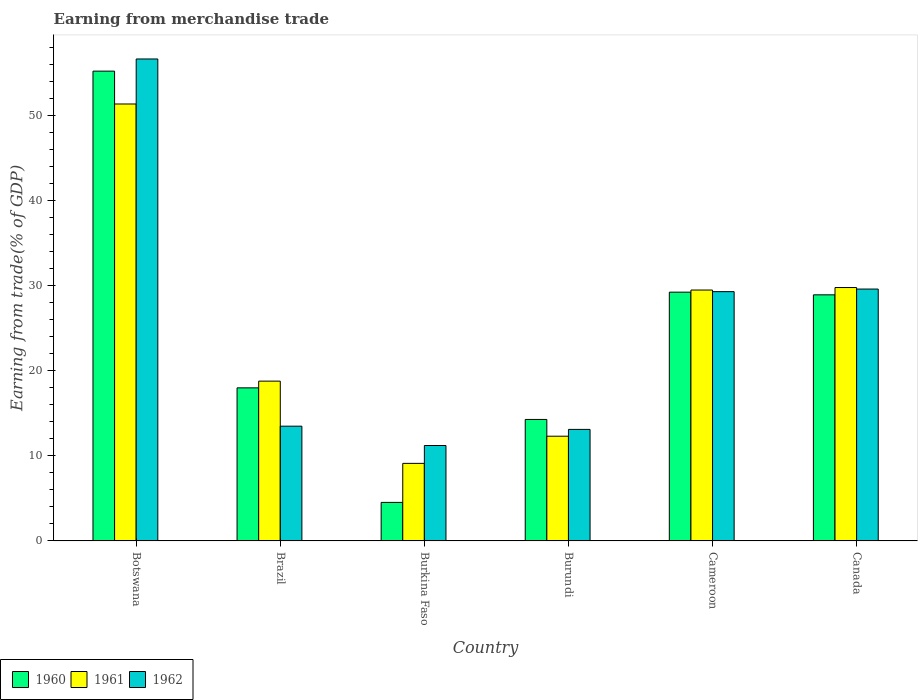How many different coloured bars are there?
Provide a short and direct response. 3. Are the number of bars per tick equal to the number of legend labels?
Provide a succinct answer. Yes. Are the number of bars on each tick of the X-axis equal?
Make the answer very short. Yes. How many bars are there on the 2nd tick from the right?
Your answer should be very brief. 3. What is the label of the 3rd group of bars from the left?
Keep it short and to the point. Burkina Faso. In how many cases, is the number of bars for a given country not equal to the number of legend labels?
Provide a short and direct response. 0. What is the earnings from trade in 1962 in Brazil?
Your response must be concise. 13.49. Across all countries, what is the maximum earnings from trade in 1961?
Keep it short and to the point. 51.38. Across all countries, what is the minimum earnings from trade in 1961?
Your answer should be very brief. 9.12. In which country was the earnings from trade in 1962 maximum?
Make the answer very short. Botswana. In which country was the earnings from trade in 1962 minimum?
Your answer should be compact. Burkina Faso. What is the total earnings from trade in 1960 in the graph?
Your answer should be very brief. 150.25. What is the difference between the earnings from trade in 1961 in Burkina Faso and that in Canada?
Make the answer very short. -20.68. What is the difference between the earnings from trade in 1960 in Burkina Faso and the earnings from trade in 1961 in Canada?
Your response must be concise. -25.26. What is the average earnings from trade in 1960 per country?
Provide a short and direct response. 25.04. What is the difference between the earnings from trade of/in 1962 and earnings from trade of/in 1961 in Canada?
Offer a very short reply. -0.18. What is the ratio of the earnings from trade in 1960 in Botswana to that in Burundi?
Provide a succinct answer. 3.87. Is the earnings from trade in 1961 in Brazil less than that in Burkina Faso?
Your answer should be very brief. No. What is the difference between the highest and the second highest earnings from trade in 1961?
Your response must be concise. -21.88. What is the difference between the highest and the lowest earnings from trade in 1961?
Provide a succinct answer. 42.26. In how many countries, is the earnings from trade in 1962 greater than the average earnings from trade in 1962 taken over all countries?
Keep it short and to the point. 3. Is the sum of the earnings from trade in 1960 in Brazil and Cameroon greater than the maximum earnings from trade in 1961 across all countries?
Ensure brevity in your answer.  No. Is it the case that in every country, the sum of the earnings from trade in 1961 and earnings from trade in 1960 is greater than the earnings from trade in 1962?
Ensure brevity in your answer.  Yes. Are the values on the major ticks of Y-axis written in scientific E-notation?
Offer a very short reply. No. Does the graph contain any zero values?
Offer a very short reply. No. Does the graph contain grids?
Your answer should be very brief. No. How many legend labels are there?
Ensure brevity in your answer.  3. What is the title of the graph?
Your response must be concise. Earning from merchandise trade. What is the label or title of the Y-axis?
Give a very brief answer. Earning from trade(% of GDP). What is the Earning from trade(% of GDP) of 1960 in Botswana?
Give a very brief answer. 55.24. What is the Earning from trade(% of GDP) in 1961 in Botswana?
Your response must be concise. 51.38. What is the Earning from trade(% of GDP) of 1962 in Botswana?
Offer a terse response. 56.67. What is the Earning from trade(% of GDP) of 1960 in Brazil?
Give a very brief answer. 18. What is the Earning from trade(% of GDP) of 1961 in Brazil?
Your response must be concise. 18.79. What is the Earning from trade(% of GDP) of 1962 in Brazil?
Your response must be concise. 13.49. What is the Earning from trade(% of GDP) of 1960 in Burkina Faso?
Provide a short and direct response. 4.53. What is the Earning from trade(% of GDP) in 1961 in Burkina Faso?
Your response must be concise. 9.12. What is the Earning from trade(% of GDP) of 1962 in Burkina Faso?
Ensure brevity in your answer.  11.22. What is the Earning from trade(% of GDP) of 1960 in Burundi?
Provide a succinct answer. 14.29. What is the Earning from trade(% of GDP) in 1961 in Burundi?
Ensure brevity in your answer.  12.32. What is the Earning from trade(% of GDP) in 1962 in Burundi?
Make the answer very short. 13.11. What is the Earning from trade(% of GDP) of 1960 in Cameroon?
Offer a terse response. 29.25. What is the Earning from trade(% of GDP) in 1961 in Cameroon?
Keep it short and to the point. 29.5. What is the Earning from trade(% of GDP) of 1962 in Cameroon?
Make the answer very short. 29.31. What is the Earning from trade(% of GDP) of 1960 in Canada?
Provide a short and direct response. 28.94. What is the Earning from trade(% of GDP) of 1961 in Canada?
Give a very brief answer. 29.8. What is the Earning from trade(% of GDP) in 1962 in Canada?
Keep it short and to the point. 29.62. Across all countries, what is the maximum Earning from trade(% of GDP) in 1960?
Ensure brevity in your answer.  55.24. Across all countries, what is the maximum Earning from trade(% of GDP) of 1961?
Your answer should be compact. 51.38. Across all countries, what is the maximum Earning from trade(% of GDP) in 1962?
Keep it short and to the point. 56.67. Across all countries, what is the minimum Earning from trade(% of GDP) of 1960?
Ensure brevity in your answer.  4.53. Across all countries, what is the minimum Earning from trade(% of GDP) of 1961?
Your answer should be very brief. 9.12. Across all countries, what is the minimum Earning from trade(% of GDP) in 1962?
Provide a succinct answer. 11.22. What is the total Earning from trade(% of GDP) of 1960 in the graph?
Make the answer very short. 150.25. What is the total Earning from trade(% of GDP) of 1961 in the graph?
Your response must be concise. 150.9. What is the total Earning from trade(% of GDP) of 1962 in the graph?
Your answer should be very brief. 153.43. What is the difference between the Earning from trade(% of GDP) in 1960 in Botswana and that in Brazil?
Offer a terse response. 37.24. What is the difference between the Earning from trade(% of GDP) of 1961 in Botswana and that in Brazil?
Give a very brief answer. 32.59. What is the difference between the Earning from trade(% of GDP) of 1962 in Botswana and that in Brazil?
Make the answer very short. 43.18. What is the difference between the Earning from trade(% of GDP) of 1960 in Botswana and that in Burkina Faso?
Keep it short and to the point. 50.71. What is the difference between the Earning from trade(% of GDP) of 1961 in Botswana and that in Burkina Faso?
Make the answer very short. 42.26. What is the difference between the Earning from trade(% of GDP) of 1962 in Botswana and that in Burkina Faso?
Keep it short and to the point. 45.45. What is the difference between the Earning from trade(% of GDP) of 1960 in Botswana and that in Burundi?
Ensure brevity in your answer.  40.96. What is the difference between the Earning from trade(% of GDP) in 1961 in Botswana and that in Burundi?
Make the answer very short. 39.06. What is the difference between the Earning from trade(% of GDP) in 1962 in Botswana and that in Burundi?
Offer a very short reply. 43.56. What is the difference between the Earning from trade(% of GDP) of 1960 in Botswana and that in Cameroon?
Keep it short and to the point. 25.99. What is the difference between the Earning from trade(% of GDP) in 1961 in Botswana and that in Cameroon?
Your answer should be very brief. 21.88. What is the difference between the Earning from trade(% of GDP) of 1962 in Botswana and that in Cameroon?
Ensure brevity in your answer.  27.36. What is the difference between the Earning from trade(% of GDP) in 1960 in Botswana and that in Canada?
Make the answer very short. 26.3. What is the difference between the Earning from trade(% of GDP) in 1961 in Botswana and that in Canada?
Your response must be concise. 21.58. What is the difference between the Earning from trade(% of GDP) in 1962 in Botswana and that in Canada?
Ensure brevity in your answer.  27.05. What is the difference between the Earning from trade(% of GDP) of 1960 in Brazil and that in Burkina Faso?
Provide a short and direct response. 13.47. What is the difference between the Earning from trade(% of GDP) in 1961 in Brazil and that in Burkina Faso?
Your response must be concise. 9.67. What is the difference between the Earning from trade(% of GDP) in 1962 in Brazil and that in Burkina Faso?
Offer a terse response. 2.27. What is the difference between the Earning from trade(% of GDP) in 1960 in Brazil and that in Burundi?
Make the answer very short. 3.72. What is the difference between the Earning from trade(% of GDP) in 1961 in Brazil and that in Burundi?
Ensure brevity in your answer.  6.47. What is the difference between the Earning from trade(% of GDP) of 1962 in Brazil and that in Burundi?
Your answer should be very brief. 0.38. What is the difference between the Earning from trade(% of GDP) in 1960 in Brazil and that in Cameroon?
Your response must be concise. -11.25. What is the difference between the Earning from trade(% of GDP) in 1961 in Brazil and that in Cameroon?
Provide a succinct answer. -10.71. What is the difference between the Earning from trade(% of GDP) in 1962 in Brazil and that in Cameroon?
Offer a terse response. -15.82. What is the difference between the Earning from trade(% of GDP) in 1960 in Brazil and that in Canada?
Make the answer very short. -10.94. What is the difference between the Earning from trade(% of GDP) in 1961 in Brazil and that in Canada?
Offer a very short reply. -11.01. What is the difference between the Earning from trade(% of GDP) of 1962 in Brazil and that in Canada?
Provide a short and direct response. -16.12. What is the difference between the Earning from trade(% of GDP) of 1960 in Burkina Faso and that in Burundi?
Your answer should be compact. -9.75. What is the difference between the Earning from trade(% of GDP) of 1961 in Burkina Faso and that in Burundi?
Provide a short and direct response. -3.19. What is the difference between the Earning from trade(% of GDP) of 1962 in Burkina Faso and that in Burundi?
Give a very brief answer. -1.89. What is the difference between the Earning from trade(% of GDP) of 1960 in Burkina Faso and that in Cameroon?
Offer a terse response. -24.72. What is the difference between the Earning from trade(% of GDP) of 1961 in Burkina Faso and that in Cameroon?
Offer a very short reply. -20.38. What is the difference between the Earning from trade(% of GDP) of 1962 in Burkina Faso and that in Cameroon?
Ensure brevity in your answer.  -18.09. What is the difference between the Earning from trade(% of GDP) in 1960 in Burkina Faso and that in Canada?
Offer a terse response. -24.41. What is the difference between the Earning from trade(% of GDP) in 1961 in Burkina Faso and that in Canada?
Your answer should be very brief. -20.68. What is the difference between the Earning from trade(% of GDP) of 1962 in Burkina Faso and that in Canada?
Your response must be concise. -18.4. What is the difference between the Earning from trade(% of GDP) in 1960 in Burundi and that in Cameroon?
Your answer should be compact. -14.97. What is the difference between the Earning from trade(% of GDP) of 1961 in Burundi and that in Cameroon?
Provide a short and direct response. -17.19. What is the difference between the Earning from trade(% of GDP) of 1962 in Burundi and that in Cameroon?
Keep it short and to the point. -16.2. What is the difference between the Earning from trade(% of GDP) of 1960 in Burundi and that in Canada?
Provide a succinct answer. -14.65. What is the difference between the Earning from trade(% of GDP) in 1961 in Burundi and that in Canada?
Provide a short and direct response. -17.48. What is the difference between the Earning from trade(% of GDP) of 1962 in Burundi and that in Canada?
Give a very brief answer. -16.5. What is the difference between the Earning from trade(% of GDP) of 1960 in Cameroon and that in Canada?
Keep it short and to the point. 0.32. What is the difference between the Earning from trade(% of GDP) of 1961 in Cameroon and that in Canada?
Your response must be concise. -0.3. What is the difference between the Earning from trade(% of GDP) of 1962 in Cameroon and that in Canada?
Your answer should be compact. -0.3. What is the difference between the Earning from trade(% of GDP) of 1960 in Botswana and the Earning from trade(% of GDP) of 1961 in Brazil?
Ensure brevity in your answer.  36.45. What is the difference between the Earning from trade(% of GDP) of 1960 in Botswana and the Earning from trade(% of GDP) of 1962 in Brazil?
Your response must be concise. 41.75. What is the difference between the Earning from trade(% of GDP) of 1961 in Botswana and the Earning from trade(% of GDP) of 1962 in Brazil?
Offer a very short reply. 37.88. What is the difference between the Earning from trade(% of GDP) in 1960 in Botswana and the Earning from trade(% of GDP) in 1961 in Burkina Faso?
Give a very brief answer. 46.12. What is the difference between the Earning from trade(% of GDP) in 1960 in Botswana and the Earning from trade(% of GDP) in 1962 in Burkina Faso?
Provide a succinct answer. 44.02. What is the difference between the Earning from trade(% of GDP) in 1961 in Botswana and the Earning from trade(% of GDP) in 1962 in Burkina Faso?
Keep it short and to the point. 40.16. What is the difference between the Earning from trade(% of GDP) in 1960 in Botswana and the Earning from trade(% of GDP) in 1961 in Burundi?
Your answer should be very brief. 42.93. What is the difference between the Earning from trade(% of GDP) in 1960 in Botswana and the Earning from trade(% of GDP) in 1962 in Burundi?
Your response must be concise. 42.13. What is the difference between the Earning from trade(% of GDP) of 1961 in Botswana and the Earning from trade(% of GDP) of 1962 in Burundi?
Your answer should be very brief. 38.26. What is the difference between the Earning from trade(% of GDP) in 1960 in Botswana and the Earning from trade(% of GDP) in 1961 in Cameroon?
Your response must be concise. 25.74. What is the difference between the Earning from trade(% of GDP) in 1960 in Botswana and the Earning from trade(% of GDP) in 1962 in Cameroon?
Your response must be concise. 25.93. What is the difference between the Earning from trade(% of GDP) of 1961 in Botswana and the Earning from trade(% of GDP) of 1962 in Cameroon?
Ensure brevity in your answer.  22.07. What is the difference between the Earning from trade(% of GDP) in 1960 in Botswana and the Earning from trade(% of GDP) in 1961 in Canada?
Make the answer very short. 25.45. What is the difference between the Earning from trade(% of GDP) of 1960 in Botswana and the Earning from trade(% of GDP) of 1962 in Canada?
Ensure brevity in your answer.  25.63. What is the difference between the Earning from trade(% of GDP) of 1961 in Botswana and the Earning from trade(% of GDP) of 1962 in Canada?
Ensure brevity in your answer.  21.76. What is the difference between the Earning from trade(% of GDP) in 1960 in Brazil and the Earning from trade(% of GDP) in 1961 in Burkina Faso?
Your answer should be compact. 8.88. What is the difference between the Earning from trade(% of GDP) in 1960 in Brazil and the Earning from trade(% of GDP) in 1962 in Burkina Faso?
Make the answer very short. 6.78. What is the difference between the Earning from trade(% of GDP) of 1961 in Brazil and the Earning from trade(% of GDP) of 1962 in Burkina Faso?
Give a very brief answer. 7.57. What is the difference between the Earning from trade(% of GDP) in 1960 in Brazil and the Earning from trade(% of GDP) in 1961 in Burundi?
Make the answer very short. 5.69. What is the difference between the Earning from trade(% of GDP) in 1960 in Brazil and the Earning from trade(% of GDP) in 1962 in Burundi?
Provide a short and direct response. 4.89. What is the difference between the Earning from trade(% of GDP) of 1961 in Brazil and the Earning from trade(% of GDP) of 1962 in Burundi?
Keep it short and to the point. 5.68. What is the difference between the Earning from trade(% of GDP) in 1960 in Brazil and the Earning from trade(% of GDP) in 1962 in Cameroon?
Offer a terse response. -11.31. What is the difference between the Earning from trade(% of GDP) of 1961 in Brazil and the Earning from trade(% of GDP) of 1962 in Cameroon?
Offer a terse response. -10.52. What is the difference between the Earning from trade(% of GDP) in 1960 in Brazil and the Earning from trade(% of GDP) in 1961 in Canada?
Ensure brevity in your answer.  -11.8. What is the difference between the Earning from trade(% of GDP) of 1960 in Brazil and the Earning from trade(% of GDP) of 1962 in Canada?
Your answer should be compact. -11.62. What is the difference between the Earning from trade(% of GDP) in 1961 in Brazil and the Earning from trade(% of GDP) in 1962 in Canada?
Keep it short and to the point. -10.83. What is the difference between the Earning from trade(% of GDP) of 1960 in Burkina Faso and the Earning from trade(% of GDP) of 1961 in Burundi?
Provide a short and direct response. -7.78. What is the difference between the Earning from trade(% of GDP) of 1960 in Burkina Faso and the Earning from trade(% of GDP) of 1962 in Burundi?
Offer a very short reply. -8.58. What is the difference between the Earning from trade(% of GDP) of 1961 in Burkina Faso and the Earning from trade(% of GDP) of 1962 in Burundi?
Give a very brief answer. -3.99. What is the difference between the Earning from trade(% of GDP) in 1960 in Burkina Faso and the Earning from trade(% of GDP) in 1961 in Cameroon?
Provide a short and direct response. -24.97. What is the difference between the Earning from trade(% of GDP) of 1960 in Burkina Faso and the Earning from trade(% of GDP) of 1962 in Cameroon?
Ensure brevity in your answer.  -24.78. What is the difference between the Earning from trade(% of GDP) of 1961 in Burkina Faso and the Earning from trade(% of GDP) of 1962 in Cameroon?
Keep it short and to the point. -20.19. What is the difference between the Earning from trade(% of GDP) of 1960 in Burkina Faso and the Earning from trade(% of GDP) of 1961 in Canada?
Keep it short and to the point. -25.26. What is the difference between the Earning from trade(% of GDP) of 1960 in Burkina Faso and the Earning from trade(% of GDP) of 1962 in Canada?
Your answer should be very brief. -25.08. What is the difference between the Earning from trade(% of GDP) of 1961 in Burkina Faso and the Earning from trade(% of GDP) of 1962 in Canada?
Your response must be concise. -20.5. What is the difference between the Earning from trade(% of GDP) of 1960 in Burundi and the Earning from trade(% of GDP) of 1961 in Cameroon?
Your response must be concise. -15.22. What is the difference between the Earning from trade(% of GDP) of 1960 in Burundi and the Earning from trade(% of GDP) of 1962 in Cameroon?
Keep it short and to the point. -15.03. What is the difference between the Earning from trade(% of GDP) of 1961 in Burundi and the Earning from trade(% of GDP) of 1962 in Cameroon?
Make the answer very short. -17. What is the difference between the Earning from trade(% of GDP) of 1960 in Burundi and the Earning from trade(% of GDP) of 1961 in Canada?
Provide a succinct answer. -15.51. What is the difference between the Earning from trade(% of GDP) in 1960 in Burundi and the Earning from trade(% of GDP) in 1962 in Canada?
Give a very brief answer. -15.33. What is the difference between the Earning from trade(% of GDP) in 1961 in Burundi and the Earning from trade(% of GDP) in 1962 in Canada?
Give a very brief answer. -17.3. What is the difference between the Earning from trade(% of GDP) in 1960 in Cameroon and the Earning from trade(% of GDP) in 1961 in Canada?
Provide a short and direct response. -0.54. What is the difference between the Earning from trade(% of GDP) in 1960 in Cameroon and the Earning from trade(% of GDP) in 1962 in Canada?
Provide a short and direct response. -0.36. What is the difference between the Earning from trade(% of GDP) in 1961 in Cameroon and the Earning from trade(% of GDP) in 1962 in Canada?
Give a very brief answer. -0.12. What is the average Earning from trade(% of GDP) in 1960 per country?
Offer a very short reply. 25.04. What is the average Earning from trade(% of GDP) in 1961 per country?
Ensure brevity in your answer.  25.15. What is the average Earning from trade(% of GDP) in 1962 per country?
Give a very brief answer. 25.57. What is the difference between the Earning from trade(% of GDP) in 1960 and Earning from trade(% of GDP) in 1961 in Botswana?
Give a very brief answer. 3.86. What is the difference between the Earning from trade(% of GDP) in 1960 and Earning from trade(% of GDP) in 1962 in Botswana?
Give a very brief answer. -1.43. What is the difference between the Earning from trade(% of GDP) of 1961 and Earning from trade(% of GDP) of 1962 in Botswana?
Offer a terse response. -5.29. What is the difference between the Earning from trade(% of GDP) in 1960 and Earning from trade(% of GDP) in 1961 in Brazil?
Give a very brief answer. -0.79. What is the difference between the Earning from trade(% of GDP) in 1960 and Earning from trade(% of GDP) in 1962 in Brazil?
Give a very brief answer. 4.51. What is the difference between the Earning from trade(% of GDP) of 1961 and Earning from trade(% of GDP) of 1962 in Brazil?
Ensure brevity in your answer.  5.3. What is the difference between the Earning from trade(% of GDP) of 1960 and Earning from trade(% of GDP) of 1961 in Burkina Faso?
Provide a short and direct response. -4.59. What is the difference between the Earning from trade(% of GDP) in 1960 and Earning from trade(% of GDP) in 1962 in Burkina Faso?
Your answer should be very brief. -6.69. What is the difference between the Earning from trade(% of GDP) in 1961 and Earning from trade(% of GDP) in 1962 in Burkina Faso?
Offer a terse response. -2.1. What is the difference between the Earning from trade(% of GDP) in 1960 and Earning from trade(% of GDP) in 1961 in Burundi?
Offer a very short reply. 1.97. What is the difference between the Earning from trade(% of GDP) in 1960 and Earning from trade(% of GDP) in 1962 in Burundi?
Your answer should be very brief. 1.17. What is the difference between the Earning from trade(% of GDP) of 1961 and Earning from trade(% of GDP) of 1962 in Burundi?
Ensure brevity in your answer.  -0.8. What is the difference between the Earning from trade(% of GDP) of 1960 and Earning from trade(% of GDP) of 1961 in Cameroon?
Your answer should be very brief. -0.25. What is the difference between the Earning from trade(% of GDP) in 1960 and Earning from trade(% of GDP) in 1962 in Cameroon?
Ensure brevity in your answer.  -0.06. What is the difference between the Earning from trade(% of GDP) of 1961 and Earning from trade(% of GDP) of 1962 in Cameroon?
Your answer should be compact. 0.19. What is the difference between the Earning from trade(% of GDP) in 1960 and Earning from trade(% of GDP) in 1961 in Canada?
Provide a succinct answer. -0.86. What is the difference between the Earning from trade(% of GDP) of 1960 and Earning from trade(% of GDP) of 1962 in Canada?
Provide a succinct answer. -0.68. What is the difference between the Earning from trade(% of GDP) in 1961 and Earning from trade(% of GDP) in 1962 in Canada?
Provide a succinct answer. 0.18. What is the ratio of the Earning from trade(% of GDP) in 1960 in Botswana to that in Brazil?
Give a very brief answer. 3.07. What is the ratio of the Earning from trade(% of GDP) of 1961 in Botswana to that in Brazil?
Your answer should be very brief. 2.73. What is the ratio of the Earning from trade(% of GDP) in 1962 in Botswana to that in Brazil?
Your answer should be compact. 4.2. What is the ratio of the Earning from trade(% of GDP) of 1960 in Botswana to that in Burkina Faso?
Provide a succinct answer. 12.19. What is the ratio of the Earning from trade(% of GDP) of 1961 in Botswana to that in Burkina Faso?
Offer a terse response. 5.63. What is the ratio of the Earning from trade(% of GDP) of 1962 in Botswana to that in Burkina Faso?
Your response must be concise. 5.05. What is the ratio of the Earning from trade(% of GDP) of 1960 in Botswana to that in Burundi?
Your answer should be very brief. 3.87. What is the ratio of the Earning from trade(% of GDP) in 1961 in Botswana to that in Burundi?
Your response must be concise. 4.17. What is the ratio of the Earning from trade(% of GDP) in 1962 in Botswana to that in Burundi?
Keep it short and to the point. 4.32. What is the ratio of the Earning from trade(% of GDP) of 1960 in Botswana to that in Cameroon?
Your response must be concise. 1.89. What is the ratio of the Earning from trade(% of GDP) in 1961 in Botswana to that in Cameroon?
Keep it short and to the point. 1.74. What is the ratio of the Earning from trade(% of GDP) in 1962 in Botswana to that in Cameroon?
Keep it short and to the point. 1.93. What is the ratio of the Earning from trade(% of GDP) of 1960 in Botswana to that in Canada?
Your answer should be compact. 1.91. What is the ratio of the Earning from trade(% of GDP) of 1961 in Botswana to that in Canada?
Provide a succinct answer. 1.72. What is the ratio of the Earning from trade(% of GDP) of 1962 in Botswana to that in Canada?
Your answer should be very brief. 1.91. What is the ratio of the Earning from trade(% of GDP) in 1960 in Brazil to that in Burkina Faso?
Offer a very short reply. 3.97. What is the ratio of the Earning from trade(% of GDP) in 1961 in Brazil to that in Burkina Faso?
Your response must be concise. 2.06. What is the ratio of the Earning from trade(% of GDP) of 1962 in Brazil to that in Burkina Faso?
Your answer should be very brief. 1.2. What is the ratio of the Earning from trade(% of GDP) of 1960 in Brazil to that in Burundi?
Give a very brief answer. 1.26. What is the ratio of the Earning from trade(% of GDP) of 1961 in Brazil to that in Burundi?
Offer a very short reply. 1.53. What is the ratio of the Earning from trade(% of GDP) in 1960 in Brazil to that in Cameroon?
Provide a short and direct response. 0.62. What is the ratio of the Earning from trade(% of GDP) of 1961 in Brazil to that in Cameroon?
Keep it short and to the point. 0.64. What is the ratio of the Earning from trade(% of GDP) of 1962 in Brazil to that in Cameroon?
Provide a succinct answer. 0.46. What is the ratio of the Earning from trade(% of GDP) in 1960 in Brazil to that in Canada?
Offer a terse response. 0.62. What is the ratio of the Earning from trade(% of GDP) in 1961 in Brazil to that in Canada?
Keep it short and to the point. 0.63. What is the ratio of the Earning from trade(% of GDP) of 1962 in Brazil to that in Canada?
Offer a very short reply. 0.46. What is the ratio of the Earning from trade(% of GDP) in 1960 in Burkina Faso to that in Burundi?
Offer a terse response. 0.32. What is the ratio of the Earning from trade(% of GDP) of 1961 in Burkina Faso to that in Burundi?
Offer a terse response. 0.74. What is the ratio of the Earning from trade(% of GDP) of 1962 in Burkina Faso to that in Burundi?
Your answer should be very brief. 0.86. What is the ratio of the Earning from trade(% of GDP) of 1960 in Burkina Faso to that in Cameroon?
Keep it short and to the point. 0.15. What is the ratio of the Earning from trade(% of GDP) in 1961 in Burkina Faso to that in Cameroon?
Ensure brevity in your answer.  0.31. What is the ratio of the Earning from trade(% of GDP) in 1962 in Burkina Faso to that in Cameroon?
Offer a very short reply. 0.38. What is the ratio of the Earning from trade(% of GDP) in 1960 in Burkina Faso to that in Canada?
Give a very brief answer. 0.16. What is the ratio of the Earning from trade(% of GDP) of 1961 in Burkina Faso to that in Canada?
Your answer should be compact. 0.31. What is the ratio of the Earning from trade(% of GDP) in 1962 in Burkina Faso to that in Canada?
Provide a short and direct response. 0.38. What is the ratio of the Earning from trade(% of GDP) of 1960 in Burundi to that in Cameroon?
Offer a terse response. 0.49. What is the ratio of the Earning from trade(% of GDP) in 1961 in Burundi to that in Cameroon?
Offer a very short reply. 0.42. What is the ratio of the Earning from trade(% of GDP) in 1962 in Burundi to that in Cameroon?
Make the answer very short. 0.45. What is the ratio of the Earning from trade(% of GDP) of 1960 in Burundi to that in Canada?
Ensure brevity in your answer.  0.49. What is the ratio of the Earning from trade(% of GDP) of 1961 in Burundi to that in Canada?
Your answer should be compact. 0.41. What is the ratio of the Earning from trade(% of GDP) of 1962 in Burundi to that in Canada?
Your response must be concise. 0.44. What is the ratio of the Earning from trade(% of GDP) in 1960 in Cameroon to that in Canada?
Offer a very short reply. 1.01. What is the difference between the highest and the second highest Earning from trade(% of GDP) in 1960?
Provide a short and direct response. 25.99. What is the difference between the highest and the second highest Earning from trade(% of GDP) in 1961?
Offer a terse response. 21.58. What is the difference between the highest and the second highest Earning from trade(% of GDP) of 1962?
Your answer should be compact. 27.05. What is the difference between the highest and the lowest Earning from trade(% of GDP) in 1960?
Your answer should be compact. 50.71. What is the difference between the highest and the lowest Earning from trade(% of GDP) in 1961?
Provide a short and direct response. 42.26. What is the difference between the highest and the lowest Earning from trade(% of GDP) of 1962?
Your answer should be compact. 45.45. 